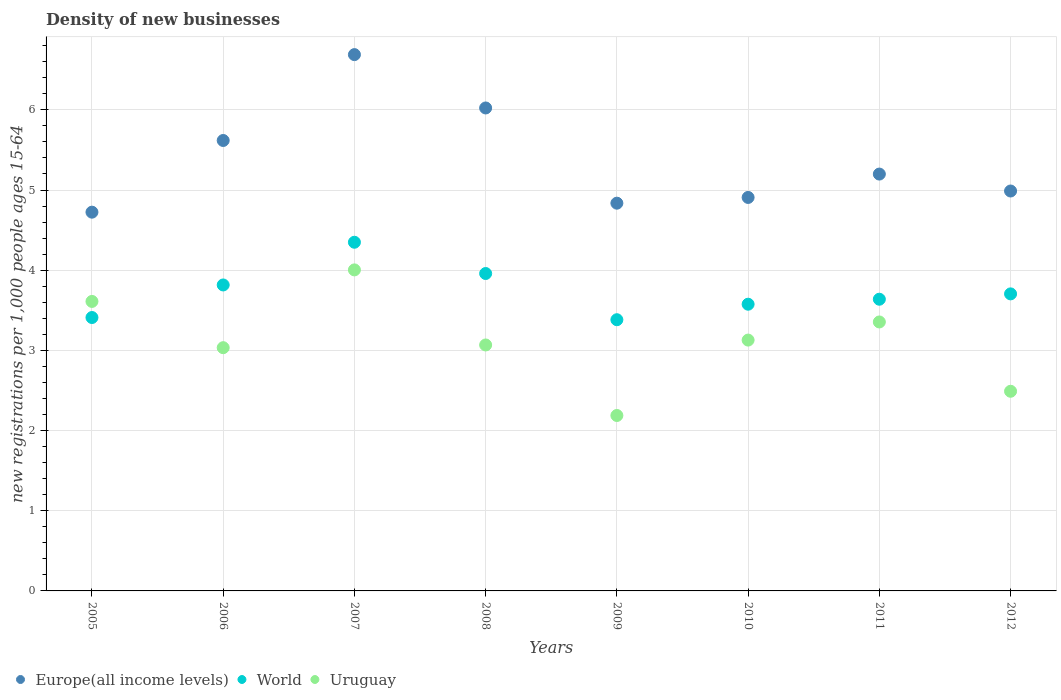Is the number of dotlines equal to the number of legend labels?
Give a very brief answer. Yes. What is the number of new registrations in Europe(all income levels) in 2010?
Offer a terse response. 4.91. Across all years, what is the maximum number of new registrations in Uruguay?
Give a very brief answer. 4. Across all years, what is the minimum number of new registrations in Europe(all income levels)?
Offer a very short reply. 4.72. What is the total number of new registrations in World in the graph?
Your response must be concise. 29.83. What is the difference between the number of new registrations in World in 2007 and that in 2012?
Ensure brevity in your answer.  0.64. What is the difference between the number of new registrations in Uruguay in 2006 and the number of new registrations in World in 2009?
Offer a very short reply. -0.35. What is the average number of new registrations in Europe(all income levels) per year?
Keep it short and to the point. 5.37. In the year 2006, what is the difference between the number of new registrations in Europe(all income levels) and number of new registrations in Uruguay?
Offer a terse response. 2.58. In how many years, is the number of new registrations in Uruguay greater than 2.2?
Offer a terse response. 7. What is the ratio of the number of new registrations in World in 2010 to that in 2012?
Your answer should be very brief. 0.97. Is the number of new registrations in Uruguay in 2005 less than that in 2011?
Make the answer very short. No. Is the difference between the number of new registrations in Europe(all income levels) in 2010 and 2012 greater than the difference between the number of new registrations in Uruguay in 2010 and 2012?
Your answer should be compact. No. What is the difference between the highest and the second highest number of new registrations in Europe(all income levels)?
Ensure brevity in your answer.  0.67. What is the difference between the highest and the lowest number of new registrations in Uruguay?
Offer a very short reply. 1.82. Is the sum of the number of new registrations in Uruguay in 2008 and 2010 greater than the maximum number of new registrations in Europe(all income levels) across all years?
Provide a short and direct response. No. Is the number of new registrations in Europe(all income levels) strictly less than the number of new registrations in Uruguay over the years?
Ensure brevity in your answer.  No. Are the values on the major ticks of Y-axis written in scientific E-notation?
Your answer should be compact. No. What is the title of the graph?
Your response must be concise. Density of new businesses. What is the label or title of the X-axis?
Provide a short and direct response. Years. What is the label or title of the Y-axis?
Keep it short and to the point. New registrations per 1,0 people ages 15-64. What is the new registrations per 1,000 people ages 15-64 in Europe(all income levels) in 2005?
Provide a short and direct response. 4.72. What is the new registrations per 1,000 people ages 15-64 in World in 2005?
Make the answer very short. 3.41. What is the new registrations per 1,000 people ages 15-64 in Uruguay in 2005?
Keep it short and to the point. 3.61. What is the new registrations per 1,000 people ages 15-64 of Europe(all income levels) in 2006?
Offer a terse response. 5.62. What is the new registrations per 1,000 people ages 15-64 of World in 2006?
Provide a short and direct response. 3.82. What is the new registrations per 1,000 people ages 15-64 in Uruguay in 2006?
Make the answer very short. 3.03. What is the new registrations per 1,000 people ages 15-64 in Europe(all income levels) in 2007?
Make the answer very short. 6.69. What is the new registrations per 1,000 people ages 15-64 in World in 2007?
Make the answer very short. 4.35. What is the new registrations per 1,000 people ages 15-64 of Uruguay in 2007?
Offer a very short reply. 4. What is the new registrations per 1,000 people ages 15-64 in Europe(all income levels) in 2008?
Your answer should be very brief. 6.02. What is the new registrations per 1,000 people ages 15-64 of World in 2008?
Keep it short and to the point. 3.96. What is the new registrations per 1,000 people ages 15-64 of Uruguay in 2008?
Provide a short and direct response. 3.07. What is the new registrations per 1,000 people ages 15-64 of Europe(all income levels) in 2009?
Provide a short and direct response. 4.84. What is the new registrations per 1,000 people ages 15-64 in World in 2009?
Offer a very short reply. 3.38. What is the new registrations per 1,000 people ages 15-64 of Uruguay in 2009?
Offer a very short reply. 2.19. What is the new registrations per 1,000 people ages 15-64 of Europe(all income levels) in 2010?
Give a very brief answer. 4.91. What is the new registrations per 1,000 people ages 15-64 in World in 2010?
Your response must be concise. 3.58. What is the new registrations per 1,000 people ages 15-64 in Uruguay in 2010?
Your response must be concise. 3.13. What is the new registrations per 1,000 people ages 15-64 of Europe(all income levels) in 2011?
Provide a succinct answer. 5.2. What is the new registrations per 1,000 people ages 15-64 in World in 2011?
Ensure brevity in your answer.  3.64. What is the new registrations per 1,000 people ages 15-64 in Uruguay in 2011?
Offer a very short reply. 3.35. What is the new registrations per 1,000 people ages 15-64 in Europe(all income levels) in 2012?
Ensure brevity in your answer.  4.99. What is the new registrations per 1,000 people ages 15-64 in World in 2012?
Provide a short and direct response. 3.7. What is the new registrations per 1,000 people ages 15-64 of Uruguay in 2012?
Keep it short and to the point. 2.49. Across all years, what is the maximum new registrations per 1,000 people ages 15-64 of Europe(all income levels)?
Make the answer very short. 6.69. Across all years, what is the maximum new registrations per 1,000 people ages 15-64 in World?
Offer a very short reply. 4.35. Across all years, what is the maximum new registrations per 1,000 people ages 15-64 in Uruguay?
Your answer should be compact. 4. Across all years, what is the minimum new registrations per 1,000 people ages 15-64 in Europe(all income levels)?
Make the answer very short. 4.72. Across all years, what is the minimum new registrations per 1,000 people ages 15-64 of World?
Offer a terse response. 3.38. Across all years, what is the minimum new registrations per 1,000 people ages 15-64 of Uruguay?
Ensure brevity in your answer.  2.19. What is the total new registrations per 1,000 people ages 15-64 in Europe(all income levels) in the graph?
Make the answer very short. 42.98. What is the total new registrations per 1,000 people ages 15-64 of World in the graph?
Ensure brevity in your answer.  29.83. What is the total new registrations per 1,000 people ages 15-64 of Uruguay in the graph?
Keep it short and to the point. 24.88. What is the difference between the new registrations per 1,000 people ages 15-64 in Europe(all income levels) in 2005 and that in 2006?
Your answer should be very brief. -0.89. What is the difference between the new registrations per 1,000 people ages 15-64 of World in 2005 and that in 2006?
Make the answer very short. -0.41. What is the difference between the new registrations per 1,000 people ages 15-64 of Uruguay in 2005 and that in 2006?
Provide a succinct answer. 0.58. What is the difference between the new registrations per 1,000 people ages 15-64 of Europe(all income levels) in 2005 and that in 2007?
Offer a very short reply. -1.96. What is the difference between the new registrations per 1,000 people ages 15-64 of World in 2005 and that in 2007?
Your answer should be very brief. -0.94. What is the difference between the new registrations per 1,000 people ages 15-64 of Uruguay in 2005 and that in 2007?
Your response must be concise. -0.39. What is the difference between the new registrations per 1,000 people ages 15-64 in Europe(all income levels) in 2005 and that in 2008?
Your response must be concise. -1.3. What is the difference between the new registrations per 1,000 people ages 15-64 in World in 2005 and that in 2008?
Ensure brevity in your answer.  -0.55. What is the difference between the new registrations per 1,000 people ages 15-64 in Uruguay in 2005 and that in 2008?
Keep it short and to the point. 0.54. What is the difference between the new registrations per 1,000 people ages 15-64 of Europe(all income levels) in 2005 and that in 2009?
Offer a terse response. -0.11. What is the difference between the new registrations per 1,000 people ages 15-64 in World in 2005 and that in 2009?
Give a very brief answer. 0.03. What is the difference between the new registrations per 1,000 people ages 15-64 in Uruguay in 2005 and that in 2009?
Your answer should be very brief. 1.42. What is the difference between the new registrations per 1,000 people ages 15-64 of Europe(all income levels) in 2005 and that in 2010?
Ensure brevity in your answer.  -0.18. What is the difference between the new registrations per 1,000 people ages 15-64 of World in 2005 and that in 2010?
Make the answer very short. -0.17. What is the difference between the new registrations per 1,000 people ages 15-64 of Uruguay in 2005 and that in 2010?
Your answer should be compact. 0.48. What is the difference between the new registrations per 1,000 people ages 15-64 of Europe(all income levels) in 2005 and that in 2011?
Ensure brevity in your answer.  -0.48. What is the difference between the new registrations per 1,000 people ages 15-64 of World in 2005 and that in 2011?
Your answer should be compact. -0.23. What is the difference between the new registrations per 1,000 people ages 15-64 of Uruguay in 2005 and that in 2011?
Ensure brevity in your answer.  0.26. What is the difference between the new registrations per 1,000 people ages 15-64 in Europe(all income levels) in 2005 and that in 2012?
Offer a terse response. -0.26. What is the difference between the new registrations per 1,000 people ages 15-64 in World in 2005 and that in 2012?
Keep it short and to the point. -0.29. What is the difference between the new registrations per 1,000 people ages 15-64 of Uruguay in 2005 and that in 2012?
Make the answer very short. 1.12. What is the difference between the new registrations per 1,000 people ages 15-64 of Europe(all income levels) in 2006 and that in 2007?
Ensure brevity in your answer.  -1.07. What is the difference between the new registrations per 1,000 people ages 15-64 of World in 2006 and that in 2007?
Provide a succinct answer. -0.53. What is the difference between the new registrations per 1,000 people ages 15-64 in Uruguay in 2006 and that in 2007?
Give a very brief answer. -0.97. What is the difference between the new registrations per 1,000 people ages 15-64 of Europe(all income levels) in 2006 and that in 2008?
Offer a very short reply. -0.41. What is the difference between the new registrations per 1,000 people ages 15-64 of World in 2006 and that in 2008?
Keep it short and to the point. -0.14. What is the difference between the new registrations per 1,000 people ages 15-64 in Uruguay in 2006 and that in 2008?
Keep it short and to the point. -0.03. What is the difference between the new registrations per 1,000 people ages 15-64 of Europe(all income levels) in 2006 and that in 2009?
Your response must be concise. 0.78. What is the difference between the new registrations per 1,000 people ages 15-64 of World in 2006 and that in 2009?
Ensure brevity in your answer.  0.43. What is the difference between the new registrations per 1,000 people ages 15-64 of Uruguay in 2006 and that in 2009?
Provide a succinct answer. 0.85. What is the difference between the new registrations per 1,000 people ages 15-64 of Europe(all income levels) in 2006 and that in 2010?
Keep it short and to the point. 0.71. What is the difference between the new registrations per 1,000 people ages 15-64 in World in 2006 and that in 2010?
Offer a very short reply. 0.24. What is the difference between the new registrations per 1,000 people ages 15-64 in Uruguay in 2006 and that in 2010?
Provide a short and direct response. -0.09. What is the difference between the new registrations per 1,000 people ages 15-64 of Europe(all income levels) in 2006 and that in 2011?
Provide a short and direct response. 0.42. What is the difference between the new registrations per 1,000 people ages 15-64 of World in 2006 and that in 2011?
Make the answer very short. 0.18. What is the difference between the new registrations per 1,000 people ages 15-64 of Uruguay in 2006 and that in 2011?
Keep it short and to the point. -0.32. What is the difference between the new registrations per 1,000 people ages 15-64 in Europe(all income levels) in 2006 and that in 2012?
Keep it short and to the point. 0.63. What is the difference between the new registrations per 1,000 people ages 15-64 in World in 2006 and that in 2012?
Make the answer very short. 0.11. What is the difference between the new registrations per 1,000 people ages 15-64 in Uruguay in 2006 and that in 2012?
Provide a succinct answer. 0.54. What is the difference between the new registrations per 1,000 people ages 15-64 in Europe(all income levels) in 2007 and that in 2008?
Your answer should be compact. 0.67. What is the difference between the new registrations per 1,000 people ages 15-64 in World in 2007 and that in 2008?
Give a very brief answer. 0.39. What is the difference between the new registrations per 1,000 people ages 15-64 in Uruguay in 2007 and that in 2008?
Your answer should be very brief. 0.94. What is the difference between the new registrations per 1,000 people ages 15-64 in Europe(all income levels) in 2007 and that in 2009?
Keep it short and to the point. 1.85. What is the difference between the new registrations per 1,000 people ages 15-64 of World in 2007 and that in 2009?
Give a very brief answer. 0.97. What is the difference between the new registrations per 1,000 people ages 15-64 of Uruguay in 2007 and that in 2009?
Offer a very short reply. 1.82. What is the difference between the new registrations per 1,000 people ages 15-64 in Europe(all income levels) in 2007 and that in 2010?
Offer a terse response. 1.78. What is the difference between the new registrations per 1,000 people ages 15-64 in World in 2007 and that in 2010?
Offer a terse response. 0.77. What is the difference between the new registrations per 1,000 people ages 15-64 of Uruguay in 2007 and that in 2010?
Give a very brief answer. 0.88. What is the difference between the new registrations per 1,000 people ages 15-64 of Europe(all income levels) in 2007 and that in 2011?
Offer a terse response. 1.49. What is the difference between the new registrations per 1,000 people ages 15-64 in World in 2007 and that in 2011?
Make the answer very short. 0.71. What is the difference between the new registrations per 1,000 people ages 15-64 in Uruguay in 2007 and that in 2011?
Keep it short and to the point. 0.65. What is the difference between the new registrations per 1,000 people ages 15-64 of Europe(all income levels) in 2007 and that in 2012?
Your response must be concise. 1.7. What is the difference between the new registrations per 1,000 people ages 15-64 in World in 2007 and that in 2012?
Make the answer very short. 0.64. What is the difference between the new registrations per 1,000 people ages 15-64 in Uruguay in 2007 and that in 2012?
Your answer should be compact. 1.51. What is the difference between the new registrations per 1,000 people ages 15-64 of Europe(all income levels) in 2008 and that in 2009?
Provide a short and direct response. 1.19. What is the difference between the new registrations per 1,000 people ages 15-64 of World in 2008 and that in 2009?
Provide a succinct answer. 0.58. What is the difference between the new registrations per 1,000 people ages 15-64 in Uruguay in 2008 and that in 2009?
Your answer should be compact. 0.88. What is the difference between the new registrations per 1,000 people ages 15-64 in Europe(all income levels) in 2008 and that in 2010?
Ensure brevity in your answer.  1.12. What is the difference between the new registrations per 1,000 people ages 15-64 of World in 2008 and that in 2010?
Make the answer very short. 0.38. What is the difference between the new registrations per 1,000 people ages 15-64 in Uruguay in 2008 and that in 2010?
Your answer should be compact. -0.06. What is the difference between the new registrations per 1,000 people ages 15-64 in Europe(all income levels) in 2008 and that in 2011?
Offer a very short reply. 0.82. What is the difference between the new registrations per 1,000 people ages 15-64 of World in 2008 and that in 2011?
Offer a terse response. 0.32. What is the difference between the new registrations per 1,000 people ages 15-64 of Uruguay in 2008 and that in 2011?
Ensure brevity in your answer.  -0.29. What is the difference between the new registrations per 1,000 people ages 15-64 in Europe(all income levels) in 2008 and that in 2012?
Offer a very short reply. 1.04. What is the difference between the new registrations per 1,000 people ages 15-64 in World in 2008 and that in 2012?
Keep it short and to the point. 0.25. What is the difference between the new registrations per 1,000 people ages 15-64 in Uruguay in 2008 and that in 2012?
Provide a succinct answer. 0.58. What is the difference between the new registrations per 1,000 people ages 15-64 of Europe(all income levels) in 2009 and that in 2010?
Provide a succinct answer. -0.07. What is the difference between the new registrations per 1,000 people ages 15-64 in World in 2009 and that in 2010?
Your answer should be compact. -0.19. What is the difference between the new registrations per 1,000 people ages 15-64 in Uruguay in 2009 and that in 2010?
Your answer should be very brief. -0.94. What is the difference between the new registrations per 1,000 people ages 15-64 in Europe(all income levels) in 2009 and that in 2011?
Offer a very short reply. -0.36. What is the difference between the new registrations per 1,000 people ages 15-64 in World in 2009 and that in 2011?
Your response must be concise. -0.26. What is the difference between the new registrations per 1,000 people ages 15-64 in Uruguay in 2009 and that in 2011?
Offer a very short reply. -1.17. What is the difference between the new registrations per 1,000 people ages 15-64 of Europe(all income levels) in 2009 and that in 2012?
Provide a succinct answer. -0.15. What is the difference between the new registrations per 1,000 people ages 15-64 in World in 2009 and that in 2012?
Keep it short and to the point. -0.32. What is the difference between the new registrations per 1,000 people ages 15-64 of Uruguay in 2009 and that in 2012?
Your answer should be very brief. -0.3. What is the difference between the new registrations per 1,000 people ages 15-64 of Europe(all income levels) in 2010 and that in 2011?
Provide a succinct answer. -0.29. What is the difference between the new registrations per 1,000 people ages 15-64 in World in 2010 and that in 2011?
Offer a terse response. -0.06. What is the difference between the new registrations per 1,000 people ages 15-64 in Uruguay in 2010 and that in 2011?
Provide a succinct answer. -0.23. What is the difference between the new registrations per 1,000 people ages 15-64 in Europe(all income levels) in 2010 and that in 2012?
Provide a short and direct response. -0.08. What is the difference between the new registrations per 1,000 people ages 15-64 of World in 2010 and that in 2012?
Provide a short and direct response. -0.13. What is the difference between the new registrations per 1,000 people ages 15-64 of Uruguay in 2010 and that in 2012?
Keep it short and to the point. 0.64. What is the difference between the new registrations per 1,000 people ages 15-64 of Europe(all income levels) in 2011 and that in 2012?
Ensure brevity in your answer.  0.21. What is the difference between the new registrations per 1,000 people ages 15-64 of World in 2011 and that in 2012?
Ensure brevity in your answer.  -0.07. What is the difference between the new registrations per 1,000 people ages 15-64 in Uruguay in 2011 and that in 2012?
Your answer should be compact. 0.86. What is the difference between the new registrations per 1,000 people ages 15-64 in Europe(all income levels) in 2005 and the new registrations per 1,000 people ages 15-64 in World in 2006?
Offer a very short reply. 0.91. What is the difference between the new registrations per 1,000 people ages 15-64 in Europe(all income levels) in 2005 and the new registrations per 1,000 people ages 15-64 in Uruguay in 2006?
Give a very brief answer. 1.69. What is the difference between the new registrations per 1,000 people ages 15-64 in World in 2005 and the new registrations per 1,000 people ages 15-64 in Uruguay in 2006?
Offer a very short reply. 0.38. What is the difference between the new registrations per 1,000 people ages 15-64 in Europe(all income levels) in 2005 and the new registrations per 1,000 people ages 15-64 in World in 2007?
Offer a very short reply. 0.38. What is the difference between the new registrations per 1,000 people ages 15-64 of Europe(all income levels) in 2005 and the new registrations per 1,000 people ages 15-64 of Uruguay in 2007?
Make the answer very short. 0.72. What is the difference between the new registrations per 1,000 people ages 15-64 in World in 2005 and the new registrations per 1,000 people ages 15-64 in Uruguay in 2007?
Keep it short and to the point. -0.59. What is the difference between the new registrations per 1,000 people ages 15-64 of Europe(all income levels) in 2005 and the new registrations per 1,000 people ages 15-64 of World in 2008?
Give a very brief answer. 0.77. What is the difference between the new registrations per 1,000 people ages 15-64 in Europe(all income levels) in 2005 and the new registrations per 1,000 people ages 15-64 in Uruguay in 2008?
Offer a very short reply. 1.66. What is the difference between the new registrations per 1,000 people ages 15-64 of World in 2005 and the new registrations per 1,000 people ages 15-64 of Uruguay in 2008?
Give a very brief answer. 0.34. What is the difference between the new registrations per 1,000 people ages 15-64 in Europe(all income levels) in 2005 and the new registrations per 1,000 people ages 15-64 in World in 2009?
Give a very brief answer. 1.34. What is the difference between the new registrations per 1,000 people ages 15-64 in Europe(all income levels) in 2005 and the new registrations per 1,000 people ages 15-64 in Uruguay in 2009?
Keep it short and to the point. 2.54. What is the difference between the new registrations per 1,000 people ages 15-64 in World in 2005 and the new registrations per 1,000 people ages 15-64 in Uruguay in 2009?
Ensure brevity in your answer.  1.22. What is the difference between the new registrations per 1,000 people ages 15-64 of Europe(all income levels) in 2005 and the new registrations per 1,000 people ages 15-64 of World in 2010?
Make the answer very short. 1.15. What is the difference between the new registrations per 1,000 people ages 15-64 in Europe(all income levels) in 2005 and the new registrations per 1,000 people ages 15-64 in Uruguay in 2010?
Provide a short and direct response. 1.6. What is the difference between the new registrations per 1,000 people ages 15-64 in World in 2005 and the new registrations per 1,000 people ages 15-64 in Uruguay in 2010?
Your response must be concise. 0.28. What is the difference between the new registrations per 1,000 people ages 15-64 in Europe(all income levels) in 2005 and the new registrations per 1,000 people ages 15-64 in World in 2011?
Make the answer very short. 1.09. What is the difference between the new registrations per 1,000 people ages 15-64 of Europe(all income levels) in 2005 and the new registrations per 1,000 people ages 15-64 of Uruguay in 2011?
Your answer should be compact. 1.37. What is the difference between the new registrations per 1,000 people ages 15-64 in World in 2005 and the new registrations per 1,000 people ages 15-64 in Uruguay in 2011?
Provide a short and direct response. 0.06. What is the difference between the new registrations per 1,000 people ages 15-64 in Europe(all income levels) in 2005 and the new registrations per 1,000 people ages 15-64 in World in 2012?
Ensure brevity in your answer.  1.02. What is the difference between the new registrations per 1,000 people ages 15-64 of Europe(all income levels) in 2005 and the new registrations per 1,000 people ages 15-64 of Uruguay in 2012?
Provide a short and direct response. 2.23. What is the difference between the new registrations per 1,000 people ages 15-64 in World in 2005 and the new registrations per 1,000 people ages 15-64 in Uruguay in 2012?
Provide a succinct answer. 0.92. What is the difference between the new registrations per 1,000 people ages 15-64 of Europe(all income levels) in 2006 and the new registrations per 1,000 people ages 15-64 of World in 2007?
Give a very brief answer. 1.27. What is the difference between the new registrations per 1,000 people ages 15-64 in Europe(all income levels) in 2006 and the new registrations per 1,000 people ages 15-64 in Uruguay in 2007?
Provide a short and direct response. 1.61. What is the difference between the new registrations per 1,000 people ages 15-64 in World in 2006 and the new registrations per 1,000 people ages 15-64 in Uruguay in 2007?
Keep it short and to the point. -0.19. What is the difference between the new registrations per 1,000 people ages 15-64 in Europe(all income levels) in 2006 and the new registrations per 1,000 people ages 15-64 in World in 2008?
Make the answer very short. 1.66. What is the difference between the new registrations per 1,000 people ages 15-64 of Europe(all income levels) in 2006 and the new registrations per 1,000 people ages 15-64 of Uruguay in 2008?
Your answer should be very brief. 2.55. What is the difference between the new registrations per 1,000 people ages 15-64 in World in 2006 and the new registrations per 1,000 people ages 15-64 in Uruguay in 2008?
Ensure brevity in your answer.  0.75. What is the difference between the new registrations per 1,000 people ages 15-64 in Europe(all income levels) in 2006 and the new registrations per 1,000 people ages 15-64 in World in 2009?
Keep it short and to the point. 2.24. What is the difference between the new registrations per 1,000 people ages 15-64 of Europe(all income levels) in 2006 and the new registrations per 1,000 people ages 15-64 of Uruguay in 2009?
Offer a very short reply. 3.43. What is the difference between the new registrations per 1,000 people ages 15-64 in World in 2006 and the new registrations per 1,000 people ages 15-64 in Uruguay in 2009?
Make the answer very short. 1.63. What is the difference between the new registrations per 1,000 people ages 15-64 of Europe(all income levels) in 2006 and the new registrations per 1,000 people ages 15-64 of World in 2010?
Ensure brevity in your answer.  2.04. What is the difference between the new registrations per 1,000 people ages 15-64 in Europe(all income levels) in 2006 and the new registrations per 1,000 people ages 15-64 in Uruguay in 2010?
Your answer should be very brief. 2.49. What is the difference between the new registrations per 1,000 people ages 15-64 of World in 2006 and the new registrations per 1,000 people ages 15-64 of Uruguay in 2010?
Make the answer very short. 0.69. What is the difference between the new registrations per 1,000 people ages 15-64 in Europe(all income levels) in 2006 and the new registrations per 1,000 people ages 15-64 in World in 2011?
Offer a very short reply. 1.98. What is the difference between the new registrations per 1,000 people ages 15-64 in Europe(all income levels) in 2006 and the new registrations per 1,000 people ages 15-64 in Uruguay in 2011?
Give a very brief answer. 2.26. What is the difference between the new registrations per 1,000 people ages 15-64 in World in 2006 and the new registrations per 1,000 people ages 15-64 in Uruguay in 2011?
Your answer should be very brief. 0.46. What is the difference between the new registrations per 1,000 people ages 15-64 of Europe(all income levels) in 2006 and the new registrations per 1,000 people ages 15-64 of World in 2012?
Your answer should be compact. 1.91. What is the difference between the new registrations per 1,000 people ages 15-64 in Europe(all income levels) in 2006 and the new registrations per 1,000 people ages 15-64 in Uruguay in 2012?
Your answer should be compact. 3.13. What is the difference between the new registrations per 1,000 people ages 15-64 of World in 2006 and the new registrations per 1,000 people ages 15-64 of Uruguay in 2012?
Keep it short and to the point. 1.33. What is the difference between the new registrations per 1,000 people ages 15-64 of Europe(all income levels) in 2007 and the new registrations per 1,000 people ages 15-64 of World in 2008?
Your answer should be compact. 2.73. What is the difference between the new registrations per 1,000 people ages 15-64 of Europe(all income levels) in 2007 and the new registrations per 1,000 people ages 15-64 of Uruguay in 2008?
Your answer should be compact. 3.62. What is the difference between the new registrations per 1,000 people ages 15-64 of World in 2007 and the new registrations per 1,000 people ages 15-64 of Uruguay in 2008?
Your answer should be very brief. 1.28. What is the difference between the new registrations per 1,000 people ages 15-64 of Europe(all income levels) in 2007 and the new registrations per 1,000 people ages 15-64 of World in 2009?
Make the answer very short. 3.31. What is the difference between the new registrations per 1,000 people ages 15-64 of Europe(all income levels) in 2007 and the new registrations per 1,000 people ages 15-64 of Uruguay in 2009?
Your answer should be compact. 4.5. What is the difference between the new registrations per 1,000 people ages 15-64 in World in 2007 and the new registrations per 1,000 people ages 15-64 in Uruguay in 2009?
Make the answer very short. 2.16. What is the difference between the new registrations per 1,000 people ages 15-64 of Europe(all income levels) in 2007 and the new registrations per 1,000 people ages 15-64 of World in 2010?
Offer a terse response. 3.11. What is the difference between the new registrations per 1,000 people ages 15-64 of Europe(all income levels) in 2007 and the new registrations per 1,000 people ages 15-64 of Uruguay in 2010?
Your answer should be compact. 3.56. What is the difference between the new registrations per 1,000 people ages 15-64 of World in 2007 and the new registrations per 1,000 people ages 15-64 of Uruguay in 2010?
Offer a terse response. 1.22. What is the difference between the new registrations per 1,000 people ages 15-64 of Europe(all income levels) in 2007 and the new registrations per 1,000 people ages 15-64 of World in 2011?
Your answer should be compact. 3.05. What is the difference between the new registrations per 1,000 people ages 15-64 of Europe(all income levels) in 2007 and the new registrations per 1,000 people ages 15-64 of Uruguay in 2011?
Keep it short and to the point. 3.33. What is the difference between the new registrations per 1,000 people ages 15-64 in World in 2007 and the new registrations per 1,000 people ages 15-64 in Uruguay in 2011?
Ensure brevity in your answer.  0.99. What is the difference between the new registrations per 1,000 people ages 15-64 in Europe(all income levels) in 2007 and the new registrations per 1,000 people ages 15-64 in World in 2012?
Keep it short and to the point. 2.98. What is the difference between the new registrations per 1,000 people ages 15-64 of Europe(all income levels) in 2007 and the new registrations per 1,000 people ages 15-64 of Uruguay in 2012?
Your answer should be very brief. 4.2. What is the difference between the new registrations per 1,000 people ages 15-64 of World in 2007 and the new registrations per 1,000 people ages 15-64 of Uruguay in 2012?
Your answer should be very brief. 1.86. What is the difference between the new registrations per 1,000 people ages 15-64 in Europe(all income levels) in 2008 and the new registrations per 1,000 people ages 15-64 in World in 2009?
Provide a succinct answer. 2.64. What is the difference between the new registrations per 1,000 people ages 15-64 in Europe(all income levels) in 2008 and the new registrations per 1,000 people ages 15-64 in Uruguay in 2009?
Keep it short and to the point. 3.84. What is the difference between the new registrations per 1,000 people ages 15-64 of World in 2008 and the new registrations per 1,000 people ages 15-64 of Uruguay in 2009?
Offer a very short reply. 1.77. What is the difference between the new registrations per 1,000 people ages 15-64 of Europe(all income levels) in 2008 and the new registrations per 1,000 people ages 15-64 of World in 2010?
Offer a terse response. 2.45. What is the difference between the new registrations per 1,000 people ages 15-64 of Europe(all income levels) in 2008 and the new registrations per 1,000 people ages 15-64 of Uruguay in 2010?
Make the answer very short. 2.89. What is the difference between the new registrations per 1,000 people ages 15-64 of World in 2008 and the new registrations per 1,000 people ages 15-64 of Uruguay in 2010?
Your answer should be compact. 0.83. What is the difference between the new registrations per 1,000 people ages 15-64 of Europe(all income levels) in 2008 and the new registrations per 1,000 people ages 15-64 of World in 2011?
Offer a very short reply. 2.39. What is the difference between the new registrations per 1,000 people ages 15-64 in Europe(all income levels) in 2008 and the new registrations per 1,000 people ages 15-64 in Uruguay in 2011?
Your response must be concise. 2.67. What is the difference between the new registrations per 1,000 people ages 15-64 of World in 2008 and the new registrations per 1,000 people ages 15-64 of Uruguay in 2011?
Provide a succinct answer. 0.6. What is the difference between the new registrations per 1,000 people ages 15-64 of Europe(all income levels) in 2008 and the new registrations per 1,000 people ages 15-64 of World in 2012?
Your answer should be very brief. 2.32. What is the difference between the new registrations per 1,000 people ages 15-64 of Europe(all income levels) in 2008 and the new registrations per 1,000 people ages 15-64 of Uruguay in 2012?
Keep it short and to the point. 3.53. What is the difference between the new registrations per 1,000 people ages 15-64 of World in 2008 and the new registrations per 1,000 people ages 15-64 of Uruguay in 2012?
Your response must be concise. 1.47. What is the difference between the new registrations per 1,000 people ages 15-64 of Europe(all income levels) in 2009 and the new registrations per 1,000 people ages 15-64 of World in 2010?
Provide a succinct answer. 1.26. What is the difference between the new registrations per 1,000 people ages 15-64 of Europe(all income levels) in 2009 and the new registrations per 1,000 people ages 15-64 of Uruguay in 2010?
Your answer should be very brief. 1.71. What is the difference between the new registrations per 1,000 people ages 15-64 of World in 2009 and the new registrations per 1,000 people ages 15-64 of Uruguay in 2010?
Your answer should be compact. 0.25. What is the difference between the new registrations per 1,000 people ages 15-64 of Europe(all income levels) in 2009 and the new registrations per 1,000 people ages 15-64 of World in 2011?
Make the answer very short. 1.2. What is the difference between the new registrations per 1,000 people ages 15-64 in Europe(all income levels) in 2009 and the new registrations per 1,000 people ages 15-64 in Uruguay in 2011?
Your answer should be very brief. 1.48. What is the difference between the new registrations per 1,000 people ages 15-64 in World in 2009 and the new registrations per 1,000 people ages 15-64 in Uruguay in 2011?
Provide a succinct answer. 0.03. What is the difference between the new registrations per 1,000 people ages 15-64 of Europe(all income levels) in 2009 and the new registrations per 1,000 people ages 15-64 of World in 2012?
Ensure brevity in your answer.  1.13. What is the difference between the new registrations per 1,000 people ages 15-64 in Europe(all income levels) in 2009 and the new registrations per 1,000 people ages 15-64 in Uruguay in 2012?
Offer a terse response. 2.35. What is the difference between the new registrations per 1,000 people ages 15-64 of World in 2009 and the new registrations per 1,000 people ages 15-64 of Uruguay in 2012?
Provide a succinct answer. 0.89. What is the difference between the new registrations per 1,000 people ages 15-64 of Europe(all income levels) in 2010 and the new registrations per 1,000 people ages 15-64 of World in 2011?
Provide a succinct answer. 1.27. What is the difference between the new registrations per 1,000 people ages 15-64 in Europe(all income levels) in 2010 and the new registrations per 1,000 people ages 15-64 in Uruguay in 2011?
Keep it short and to the point. 1.55. What is the difference between the new registrations per 1,000 people ages 15-64 in World in 2010 and the new registrations per 1,000 people ages 15-64 in Uruguay in 2011?
Provide a succinct answer. 0.22. What is the difference between the new registrations per 1,000 people ages 15-64 of Europe(all income levels) in 2010 and the new registrations per 1,000 people ages 15-64 of World in 2012?
Provide a short and direct response. 1.2. What is the difference between the new registrations per 1,000 people ages 15-64 in Europe(all income levels) in 2010 and the new registrations per 1,000 people ages 15-64 in Uruguay in 2012?
Make the answer very short. 2.42. What is the difference between the new registrations per 1,000 people ages 15-64 in World in 2010 and the new registrations per 1,000 people ages 15-64 in Uruguay in 2012?
Ensure brevity in your answer.  1.09. What is the difference between the new registrations per 1,000 people ages 15-64 of Europe(all income levels) in 2011 and the new registrations per 1,000 people ages 15-64 of World in 2012?
Your answer should be very brief. 1.49. What is the difference between the new registrations per 1,000 people ages 15-64 of Europe(all income levels) in 2011 and the new registrations per 1,000 people ages 15-64 of Uruguay in 2012?
Ensure brevity in your answer.  2.71. What is the difference between the new registrations per 1,000 people ages 15-64 of World in 2011 and the new registrations per 1,000 people ages 15-64 of Uruguay in 2012?
Provide a succinct answer. 1.15. What is the average new registrations per 1,000 people ages 15-64 in Europe(all income levels) per year?
Give a very brief answer. 5.37. What is the average new registrations per 1,000 people ages 15-64 in World per year?
Offer a terse response. 3.73. What is the average new registrations per 1,000 people ages 15-64 in Uruguay per year?
Provide a short and direct response. 3.11. In the year 2005, what is the difference between the new registrations per 1,000 people ages 15-64 of Europe(all income levels) and new registrations per 1,000 people ages 15-64 of World?
Make the answer very short. 1.31. In the year 2005, what is the difference between the new registrations per 1,000 people ages 15-64 in Europe(all income levels) and new registrations per 1,000 people ages 15-64 in Uruguay?
Provide a succinct answer. 1.11. In the year 2005, what is the difference between the new registrations per 1,000 people ages 15-64 of World and new registrations per 1,000 people ages 15-64 of Uruguay?
Provide a succinct answer. -0.2. In the year 2006, what is the difference between the new registrations per 1,000 people ages 15-64 in Europe(all income levels) and new registrations per 1,000 people ages 15-64 in World?
Provide a succinct answer. 1.8. In the year 2006, what is the difference between the new registrations per 1,000 people ages 15-64 in Europe(all income levels) and new registrations per 1,000 people ages 15-64 in Uruguay?
Your answer should be compact. 2.58. In the year 2006, what is the difference between the new registrations per 1,000 people ages 15-64 of World and new registrations per 1,000 people ages 15-64 of Uruguay?
Offer a terse response. 0.78. In the year 2007, what is the difference between the new registrations per 1,000 people ages 15-64 in Europe(all income levels) and new registrations per 1,000 people ages 15-64 in World?
Offer a very short reply. 2.34. In the year 2007, what is the difference between the new registrations per 1,000 people ages 15-64 in Europe(all income levels) and new registrations per 1,000 people ages 15-64 in Uruguay?
Your response must be concise. 2.68. In the year 2007, what is the difference between the new registrations per 1,000 people ages 15-64 of World and new registrations per 1,000 people ages 15-64 of Uruguay?
Provide a short and direct response. 0.34. In the year 2008, what is the difference between the new registrations per 1,000 people ages 15-64 of Europe(all income levels) and new registrations per 1,000 people ages 15-64 of World?
Give a very brief answer. 2.06. In the year 2008, what is the difference between the new registrations per 1,000 people ages 15-64 in Europe(all income levels) and new registrations per 1,000 people ages 15-64 in Uruguay?
Offer a very short reply. 2.96. In the year 2008, what is the difference between the new registrations per 1,000 people ages 15-64 of World and new registrations per 1,000 people ages 15-64 of Uruguay?
Keep it short and to the point. 0.89. In the year 2009, what is the difference between the new registrations per 1,000 people ages 15-64 of Europe(all income levels) and new registrations per 1,000 people ages 15-64 of World?
Give a very brief answer. 1.45. In the year 2009, what is the difference between the new registrations per 1,000 people ages 15-64 of Europe(all income levels) and new registrations per 1,000 people ages 15-64 of Uruguay?
Your answer should be compact. 2.65. In the year 2009, what is the difference between the new registrations per 1,000 people ages 15-64 of World and new registrations per 1,000 people ages 15-64 of Uruguay?
Keep it short and to the point. 1.19. In the year 2010, what is the difference between the new registrations per 1,000 people ages 15-64 in Europe(all income levels) and new registrations per 1,000 people ages 15-64 in World?
Your response must be concise. 1.33. In the year 2010, what is the difference between the new registrations per 1,000 people ages 15-64 in Europe(all income levels) and new registrations per 1,000 people ages 15-64 in Uruguay?
Your answer should be compact. 1.78. In the year 2010, what is the difference between the new registrations per 1,000 people ages 15-64 of World and new registrations per 1,000 people ages 15-64 of Uruguay?
Keep it short and to the point. 0.45. In the year 2011, what is the difference between the new registrations per 1,000 people ages 15-64 in Europe(all income levels) and new registrations per 1,000 people ages 15-64 in World?
Your response must be concise. 1.56. In the year 2011, what is the difference between the new registrations per 1,000 people ages 15-64 of Europe(all income levels) and new registrations per 1,000 people ages 15-64 of Uruguay?
Keep it short and to the point. 1.84. In the year 2011, what is the difference between the new registrations per 1,000 people ages 15-64 in World and new registrations per 1,000 people ages 15-64 in Uruguay?
Ensure brevity in your answer.  0.28. In the year 2012, what is the difference between the new registrations per 1,000 people ages 15-64 in Europe(all income levels) and new registrations per 1,000 people ages 15-64 in World?
Ensure brevity in your answer.  1.28. In the year 2012, what is the difference between the new registrations per 1,000 people ages 15-64 in Europe(all income levels) and new registrations per 1,000 people ages 15-64 in Uruguay?
Provide a succinct answer. 2.5. In the year 2012, what is the difference between the new registrations per 1,000 people ages 15-64 of World and new registrations per 1,000 people ages 15-64 of Uruguay?
Provide a short and direct response. 1.21. What is the ratio of the new registrations per 1,000 people ages 15-64 in Europe(all income levels) in 2005 to that in 2006?
Provide a short and direct response. 0.84. What is the ratio of the new registrations per 1,000 people ages 15-64 in World in 2005 to that in 2006?
Offer a terse response. 0.89. What is the ratio of the new registrations per 1,000 people ages 15-64 in Uruguay in 2005 to that in 2006?
Provide a succinct answer. 1.19. What is the ratio of the new registrations per 1,000 people ages 15-64 of Europe(all income levels) in 2005 to that in 2007?
Provide a succinct answer. 0.71. What is the ratio of the new registrations per 1,000 people ages 15-64 in World in 2005 to that in 2007?
Give a very brief answer. 0.78. What is the ratio of the new registrations per 1,000 people ages 15-64 in Uruguay in 2005 to that in 2007?
Provide a succinct answer. 0.9. What is the ratio of the new registrations per 1,000 people ages 15-64 in Europe(all income levels) in 2005 to that in 2008?
Keep it short and to the point. 0.78. What is the ratio of the new registrations per 1,000 people ages 15-64 in World in 2005 to that in 2008?
Ensure brevity in your answer.  0.86. What is the ratio of the new registrations per 1,000 people ages 15-64 of Uruguay in 2005 to that in 2008?
Your response must be concise. 1.18. What is the ratio of the new registrations per 1,000 people ages 15-64 of Europe(all income levels) in 2005 to that in 2009?
Ensure brevity in your answer.  0.98. What is the ratio of the new registrations per 1,000 people ages 15-64 of World in 2005 to that in 2009?
Your answer should be compact. 1.01. What is the ratio of the new registrations per 1,000 people ages 15-64 in Uruguay in 2005 to that in 2009?
Ensure brevity in your answer.  1.65. What is the ratio of the new registrations per 1,000 people ages 15-64 in Europe(all income levels) in 2005 to that in 2010?
Offer a terse response. 0.96. What is the ratio of the new registrations per 1,000 people ages 15-64 of World in 2005 to that in 2010?
Your answer should be compact. 0.95. What is the ratio of the new registrations per 1,000 people ages 15-64 in Uruguay in 2005 to that in 2010?
Provide a succinct answer. 1.15. What is the ratio of the new registrations per 1,000 people ages 15-64 in Europe(all income levels) in 2005 to that in 2011?
Keep it short and to the point. 0.91. What is the ratio of the new registrations per 1,000 people ages 15-64 in World in 2005 to that in 2011?
Give a very brief answer. 0.94. What is the ratio of the new registrations per 1,000 people ages 15-64 in Uruguay in 2005 to that in 2011?
Provide a short and direct response. 1.08. What is the ratio of the new registrations per 1,000 people ages 15-64 of Europe(all income levels) in 2005 to that in 2012?
Provide a succinct answer. 0.95. What is the ratio of the new registrations per 1,000 people ages 15-64 of World in 2005 to that in 2012?
Make the answer very short. 0.92. What is the ratio of the new registrations per 1,000 people ages 15-64 in Uruguay in 2005 to that in 2012?
Provide a short and direct response. 1.45. What is the ratio of the new registrations per 1,000 people ages 15-64 of Europe(all income levels) in 2006 to that in 2007?
Your answer should be very brief. 0.84. What is the ratio of the new registrations per 1,000 people ages 15-64 of World in 2006 to that in 2007?
Offer a very short reply. 0.88. What is the ratio of the new registrations per 1,000 people ages 15-64 in Uruguay in 2006 to that in 2007?
Offer a very short reply. 0.76. What is the ratio of the new registrations per 1,000 people ages 15-64 in Europe(all income levels) in 2006 to that in 2008?
Keep it short and to the point. 0.93. What is the ratio of the new registrations per 1,000 people ages 15-64 in Uruguay in 2006 to that in 2008?
Give a very brief answer. 0.99. What is the ratio of the new registrations per 1,000 people ages 15-64 of Europe(all income levels) in 2006 to that in 2009?
Provide a succinct answer. 1.16. What is the ratio of the new registrations per 1,000 people ages 15-64 of World in 2006 to that in 2009?
Your answer should be compact. 1.13. What is the ratio of the new registrations per 1,000 people ages 15-64 in Uruguay in 2006 to that in 2009?
Provide a succinct answer. 1.39. What is the ratio of the new registrations per 1,000 people ages 15-64 in Europe(all income levels) in 2006 to that in 2010?
Ensure brevity in your answer.  1.14. What is the ratio of the new registrations per 1,000 people ages 15-64 in World in 2006 to that in 2010?
Your response must be concise. 1.07. What is the ratio of the new registrations per 1,000 people ages 15-64 of Uruguay in 2006 to that in 2010?
Your answer should be very brief. 0.97. What is the ratio of the new registrations per 1,000 people ages 15-64 in Europe(all income levels) in 2006 to that in 2011?
Provide a short and direct response. 1.08. What is the ratio of the new registrations per 1,000 people ages 15-64 in World in 2006 to that in 2011?
Your answer should be compact. 1.05. What is the ratio of the new registrations per 1,000 people ages 15-64 of Uruguay in 2006 to that in 2011?
Offer a very short reply. 0.9. What is the ratio of the new registrations per 1,000 people ages 15-64 in Europe(all income levels) in 2006 to that in 2012?
Ensure brevity in your answer.  1.13. What is the ratio of the new registrations per 1,000 people ages 15-64 in World in 2006 to that in 2012?
Offer a very short reply. 1.03. What is the ratio of the new registrations per 1,000 people ages 15-64 of Uruguay in 2006 to that in 2012?
Give a very brief answer. 1.22. What is the ratio of the new registrations per 1,000 people ages 15-64 of Europe(all income levels) in 2007 to that in 2008?
Make the answer very short. 1.11. What is the ratio of the new registrations per 1,000 people ages 15-64 in World in 2007 to that in 2008?
Provide a short and direct response. 1.1. What is the ratio of the new registrations per 1,000 people ages 15-64 of Uruguay in 2007 to that in 2008?
Offer a terse response. 1.31. What is the ratio of the new registrations per 1,000 people ages 15-64 in Europe(all income levels) in 2007 to that in 2009?
Give a very brief answer. 1.38. What is the ratio of the new registrations per 1,000 people ages 15-64 of World in 2007 to that in 2009?
Give a very brief answer. 1.29. What is the ratio of the new registrations per 1,000 people ages 15-64 of Uruguay in 2007 to that in 2009?
Provide a short and direct response. 1.83. What is the ratio of the new registrations per 1,000 people ages 15-64 in Europe(all income levels) in 2007 to that in 2010?
Your answer should be compact. 1.36. What is the ratio of the new registrations per 1,000 people ages 15-64 in World in 2007 to that in 2010?
Offer a terse response. 1.22. What is the ratio of the new registrations per 1,000 people ages 15-64 of Uruguay in 2007 to that in 2010?
Ensure brevity in your answer.  1.28. What is the ratio of the new registrations per 1,000 people ages 15-64 in Europe(all income levels) in 2007 to that in 2011?
Your response must be concise. 1.29. What is the ratio of the new registrations per 1,000 people ages 15-64 of World in 2007 to that in 2011?
Your response must be concise. 1.2. What is the ratio of the new registrations per 1,000 people ages 15-64 in Uruguay in 2007 to that in 2011?
Offer a very short reply. 1.19. What is the ratio of the new registrations per 1,000 people ages 15-64 of Europe(all income levels) in 2007 to that in 2012?
Provide a short and direct response. 1.34. What is the ratio of the new registrations per 1,000 people ages 15-64 of World in 2007 to that in 2012?
Ensure brevity in your answer.  1.17. What is the ratio of the new registrations per 1,000 people ages 15-64 of Uruguay in 2007 to that in 2012?
Offer a terse response. 1.61. What is the ratio of the new registrations per 1,000 people ages 15-64 in Europe(all income levels) in 2008 to that in 2009?
Your response must be concise. 1.25. What is the ratio of the new registrations per 1,000 people ages 15-64 of World in 2008 to that in 2009?
Give a very brief answer. 1.17. What is the ratio of the new registrations per 1,000 people ages 15-64 of Uruguay in 2008 to that in 2009?
Provide a succinct answer. 1.4. What is the ratio of the new registrations per 1,000 people ages 15-64 of Europe(all income levels) in 2008 to that in 2010?
Offer a terse response. 1.23. What is the ratio of the new registrations per 1,000 people ages 15-64 of World in 2008 to that in 2010?
Make the answer very short. 1.11. What is the ratio of the new registrations per 1,000 people ages 15-64 of Uruguay in 2008 to that in 2010?
Offer a terse response. 0.98. What is the ratio of the new registrations per 1,000 people ages 15-64 in Europe(all income levels) in 2008 to that in 2011?
Provide a short and direct response. 1.16. What is the ratio of the new registrations per 1,000 people ages 15-64 in World in 2008 to that in 2011?
Keep it short and to the point. 1.09. What is the ratio of the new registrations per 1,000 people ages 15-64 in Uruguay in 2008 to that in 2011?
Ensure brevity in your answer.  0.91. What is the ratio of the new registrations per 1,000 people ages 15-64 in Europe(all income levels) in 2008 to that in 2012?
Your response must be concise. 1.21. What is the ratio of the new registrations per 1,000 people ages 15-64 of World in 2008 to that in 2012?
Offer a terse response. 1.07. What is the ratio of the new registrations per 1,000 people ages 15-64 of Uruguay in 2008 to that in 2012?
Offer a terse response. 1.23. What is the ratio of the new registrations per 1,000 people ages 15-64 in Europe(all income levels) in 2009 to that in 2010?
Make the answer very short. 0.99. What is the ratio of the new registrations per 1,000 people ages 15-64 of World in 2009 to that in 2010?
Your answer should be very brief. 0.95. What is the ratio of the new registrations per 1,000 people ages 15-64 of Uruguay in 2009 to that in 2010?
Your answer should be compact. 0.7. What is the ratio of the new registrations per 1,000 people ages 15-64 in Europe(all income levels) in 2009 to that in 2011?
Your answer should be compact. 0.93. What is the ratio of the new registrations per 1,000 people ages 15-64 of World in 2009 to that in 2011?
Make the answer very short. 0.93. What is the ratio of the new registrations per 1,000 people ages 15-64 of Uruguay in 2009 to that in 2011?
Give a very brief answer. 0.65. What is the ratio of the new registrations per 1,000 people ages 15-64 of Europe(all income levels) in 2009 to that in 2012?
Provide a short and direct response. 0.97. What is the ratio of the new registrations per 1,000 people ages 15-64 of Uruguay in 2009 to that in 2012?
Make the answer very short. 0.88. What is the ratio of the new registrations per 1,000 people ages 15-64 of Europe(all income levels) in 2010 to that in 2011?
Provide a short and direct response. 0.94. What is the ratio of the new registrations per 1,000 people ages 15-64 in World in 2010 to that in 2011?
Give a very brief answer. 0.98. What is the ratio of the new registrations per 1,000 people ages 15-64 in Uruguay in 2010 to that in 2011?
Keep it short and to the point. 0.93. What is the ratio of the new registrations per 1,000 people ages 15-64 of Europe(all income levels) in 2010 to that in 2012?
Give a very brief answer. 0.98. What is the ratio of the new registrations per 1,000 people ages 15-64 of World in 2010 to that in 2012?
Keep it short and to the point. 0.97. What is the ratio of the new registrations per 1,000 people ages 15-64 in Uruguay in 2010 to that in 2012?
Provide a succinct answer. 1.26. What is the ratio of the new registrations per 1,000 people ages 15-64 in Europe(all income levels) in 2011 to that in 2012?
Offer a terse response. 1.04. What is the ratio of the new registrations per 1,000 people ages 15-64 of Uruguay in 2011 to that in 2012?
Make the answer very short. 1.35. What is the difference between the highest and the second highest new registrations per 1,000 people ages 15-64 of Europe(all income levels)?
Your answer should be compact. 0.67. What is the difference between the highest and the second highest new registrations per 1,000 people ages 15-64 of World?
Keep it short and to the point. 0.39. What is the difference between the highest and the second highest new registrations per 1,000 people ages 15-64 in Uruguay?
Offer a very short reply. 0.39. What is the difference between the highest and the lowest new registrations per 1,000 people ages 15-64 of Europe(all income levels)?
Keep it short and to the point. 1.96. What is the difference between the highest and the lowest new registrations per 1,000 people ages 15-64 of World?
Offer a terse response. 0.97. What is the difference between the highest and the lowest new registrations per 1,000 people ages 15-64 in Uruguay?
Provide a succinct answer. 1.82. 